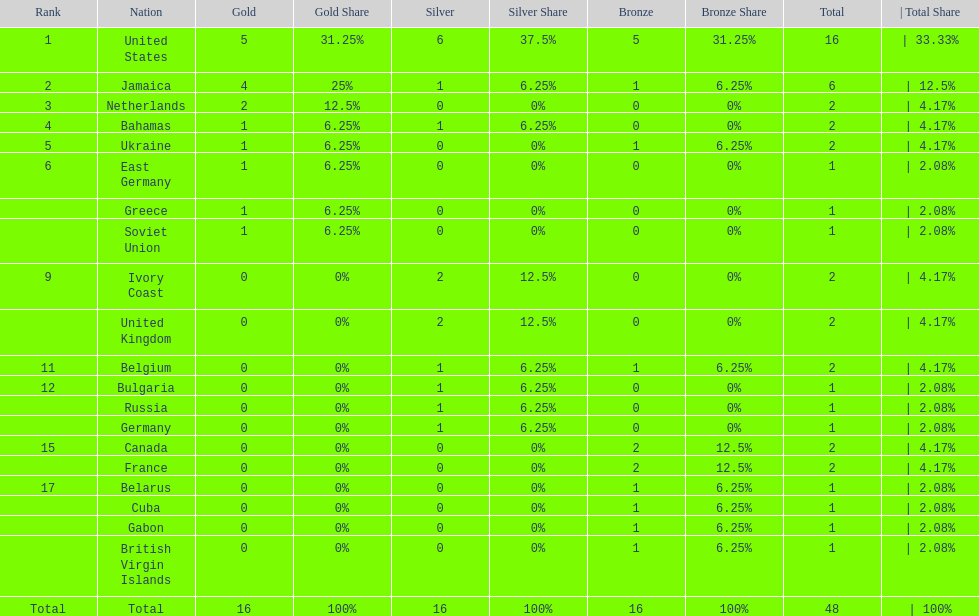How many nations won at least two gold medals? 3. 